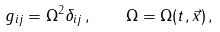Convert formula to latex. <formula><loc_0><loc_0><loc_500><loc_500>g _ { i j } = \Omega ^ { 2 } \delta _ { i j } \, , \quad \Omega = \Omega ( t , \vec { x } ) \, ,</formula> 